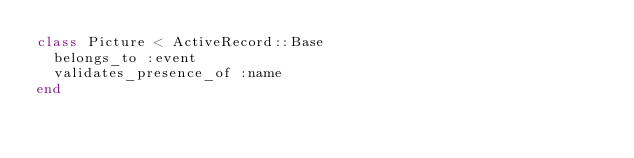<code> <loc_0><loc_0><loc_500><loc_500><_Ruby_>class Picture < ActiveRecord::Base
  belongs_to :event
  validates_presence_of :name
end
</code> 